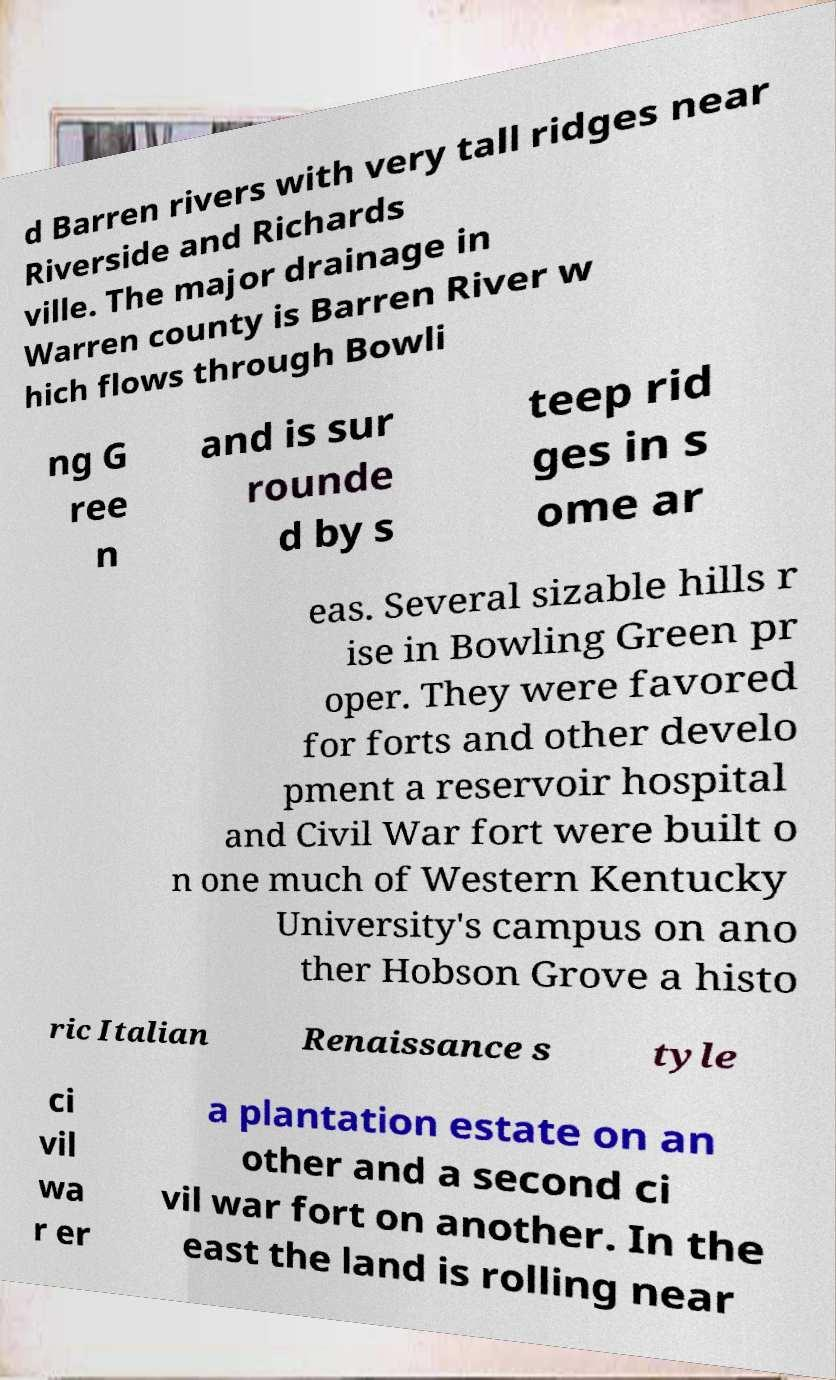Can you accurately transcribe the text from the provided image for me? d Barren rivers with very tall ridges near Riverside and Richards ville. The major drainage in Warren county is Barren River w hich flows through Bowli ng G ree n and is sur rounde d by s teep rid ges in s ome ar eas. Several sizable hills r ise in Bowling Green pr oper. They were favored for forts and other develo pment a reservoir hospital and Civil War fort were built o n one much of Western Kentucky University's campus on ano ther Hobson Grove a histo ric Italian Renaissance s tyle ci vil wa r er a plantation estate on an other and a second ci vil war fort on another. In the east the land is rolling near 